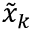Convert formula to latex. <formula><loc_0><loc_0><loc_500><loc_500>\tilde { x } _ { k }</formula> 